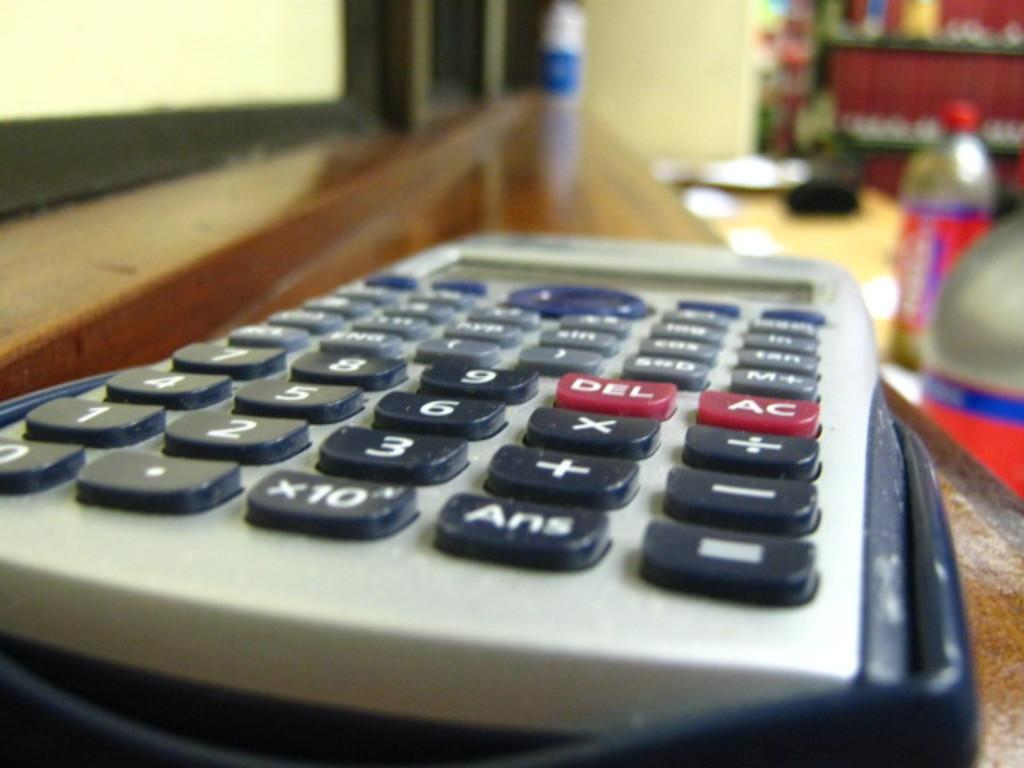<image>
Summarize the visual content of the image. the letters DEL are on the red button on the calculator 